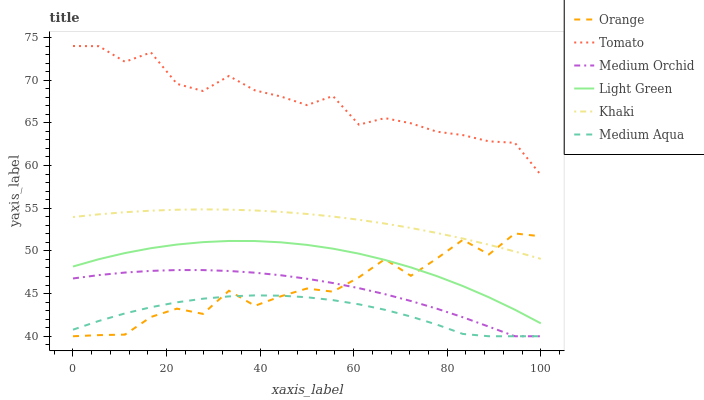Does Medium Aqua have the minimum area under the curve?
Answer yes or no. Yes. Does Tomato have the maximum area under the curve?
Answer yes or no. Yes. Does Khaki have the minimum area under the curve?
Answer yes or no. No. Does Khaki have the maximum area under the curve?
Answer yes or no. No. Is Khaki the smoothest?
Answer yes or no. Yes. Is Orange the roughest?
Answer yes or no. Yes. Is Medium Orchid the smoothest?
Answer yes or no. No. Is Medium Orchid the roughest?
Answer yes or no. No. Does Khaki have the lowest value?
Answer yes or no. No. Does Khaki have the highest value?
Answer yes or no. No. Is Medium Orchid less than Khaki?
Answer yes or no. Yes. Is Tomato greater than Light Green?
Answer yes or no. Yes. Does Medium Orchid intersect Khaki?
Answer yes or no. No. 